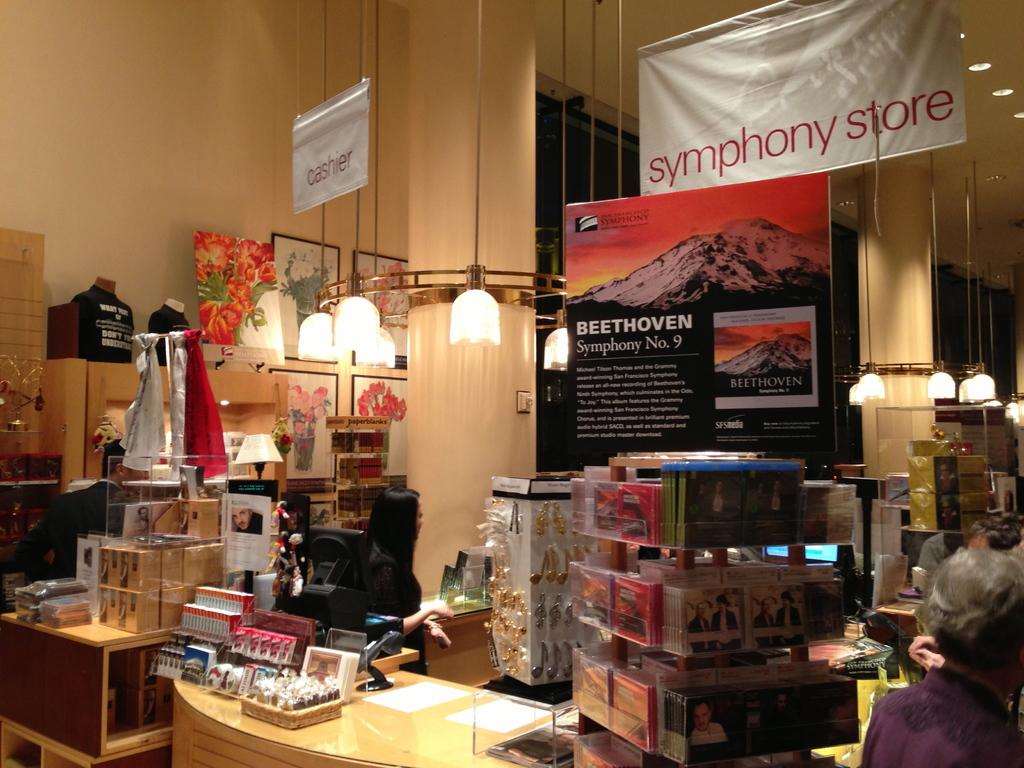<image>
Offer a succinct explanation of the picture presented. A display and cash register inside the symphony store. 